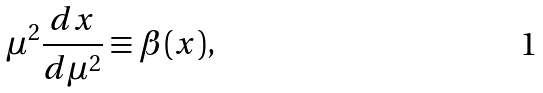<formula> <loc_0><loc_0><loc_500><loc_500>\mu ^ { 2 } \frac { d x } { d \mu ^ { 2 } } \equiv \beta ( x ) ,</formula> 